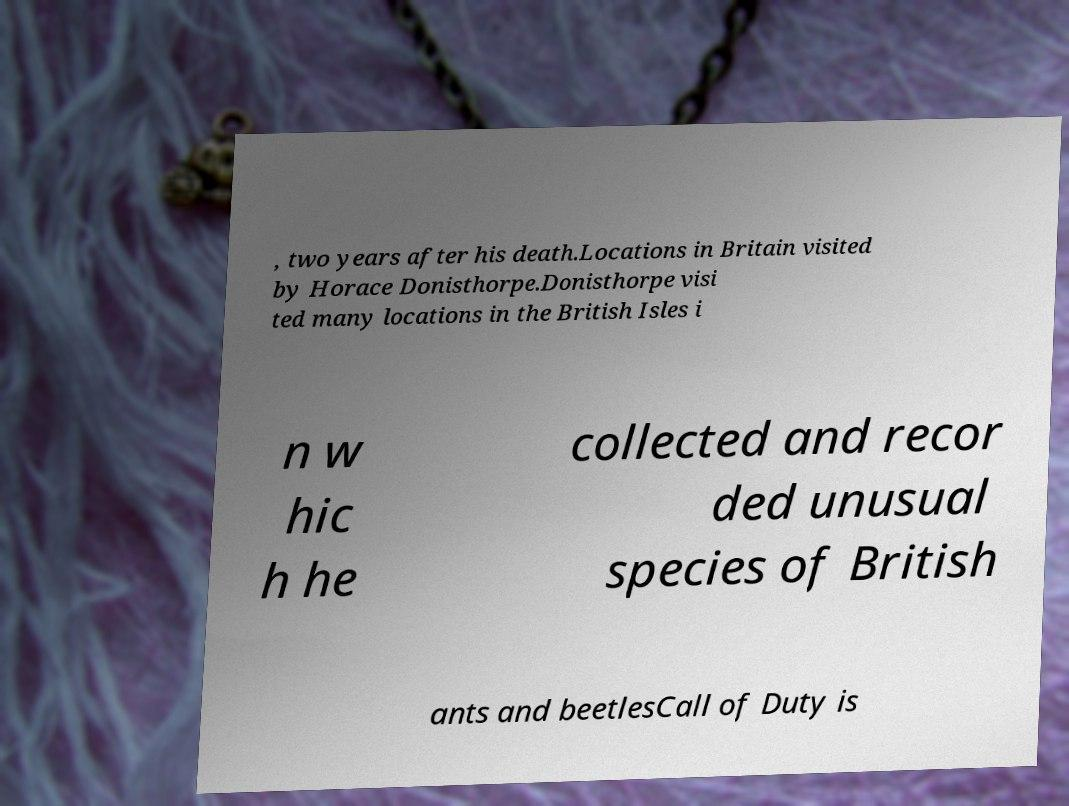Could you assist in decoding the text presented in this image and type it out clearly? , two years after his death.Locations in Britain visited by Horace Donisthorpe.Donisthorpe visi ted many locations in the British Isles i n w hic h he collected and recor ded unusual species of British ants and beetlesCall of Duty is 